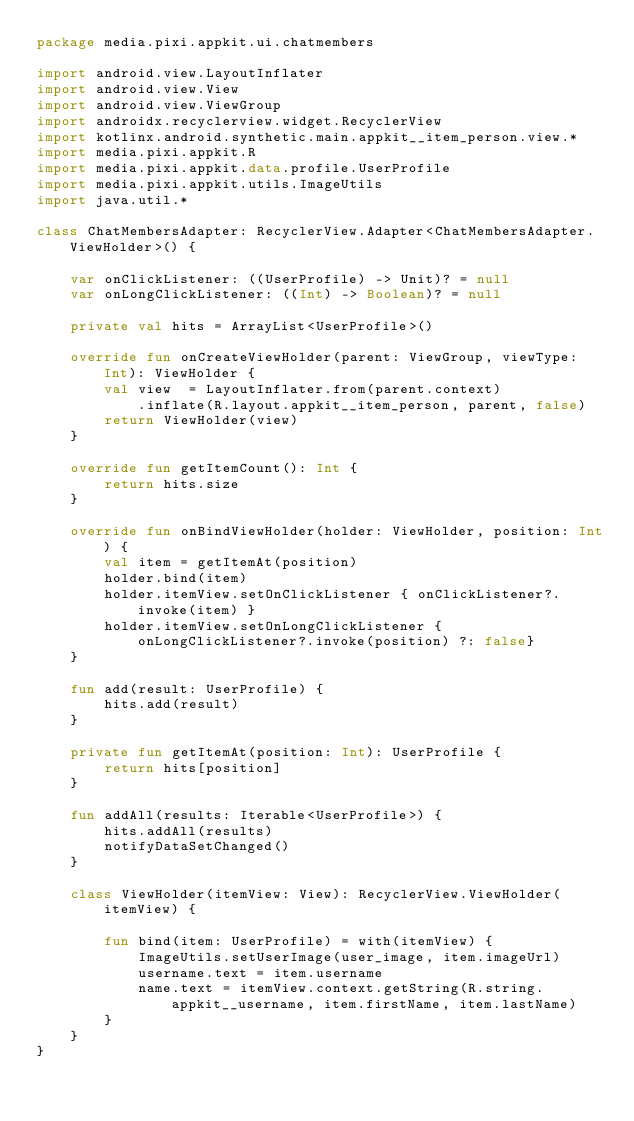<code> <loc_0><loc_0><loc_500><loc_500><_Kotlin_>package media.pixi.appkit.ui.chatmembers

import android.view.LayoutInflater
import android.view.View
import android.view.ViewGroup
import androidx.recyclerview.widget.RecyclerView
import kotlinx.android.synthetic.main.appkit__item_person.view.*
import media.pixi.appkit.R
import media.pixi.appkit.data.profile.UserProfile
import media.pixi.appkit.utils.ImageUtils
import java.util.*

class ChatMembersAdapter: RecyclerView.Adapter<ChatMembersAdapter.ViewHolder>() {

    var onClickListener: ((UserProfile) -> Unit)? = null
    var onLongClickListener: ((Int) -> Boolean)? = null

    private val hits = ArrayList<UserProfile>()

    override fun onCreateViewHolder(parent: ViewGroup, viewType: Int): ViewHolder {
        val view  = LayoutInflater.from(parent.context)
            .inflate(R.layout.appkit__item_person, parent, false)
        return ViewHolder(view)
    }

    override fun getItemCount(): Int {
        return hits.size
    }

    override fun onBindViewHolder(holder: ViewHolder, position: Int) {
        val item = getItemAt(position)
        holder.bind(item)
        holder.itemView.setOnClickListener { onClickListener?.invoke(item) }
        holder.itemView.setOnLongClickListener { onLongClickListener?.invoke(position) ?: false}
    }

    fun add(result: UserProfile) {
        hits.add(result)
    }

    private fun getItemAt(position: Int): UserProfile {
        return hits[position]
    }

    fun addAll(results: Iterable<UserProfile>) {
        hits.addAll(results)
        notifyDataSetChanged()
    }

    class ViewHolder(itemView: View): RecyclerView.ViewHolder(itemView) {

        fun bind(item: UserProfile) = with(itemView) {
            ImageUtils.setUserImage(user_image, item.imageUrl)
            username.text = item.username
            name.text = itemView.context.getString(R.string.appkit__username, item.firstName, item.lastName)
        }
    }
}</code> 